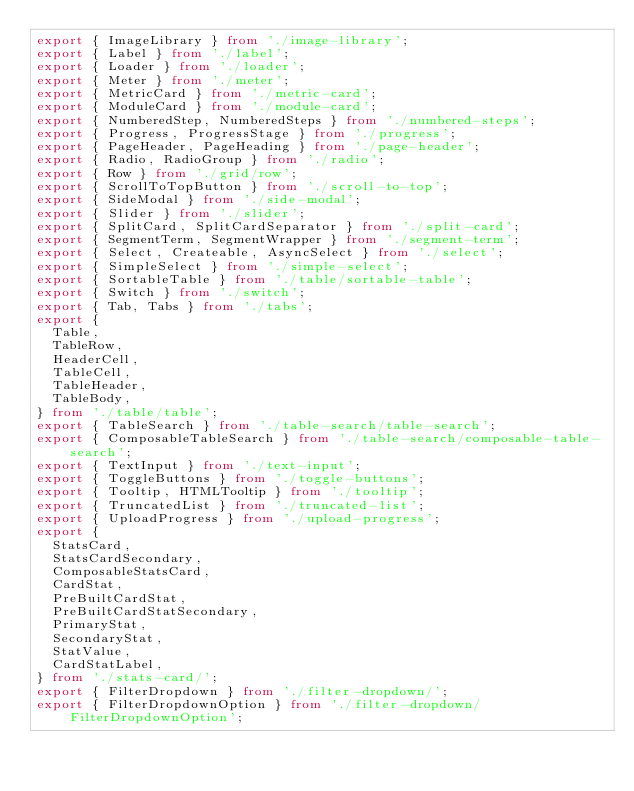<code> <loc_0><loc_0><loc_500><loc_500><_TypeScript_>export { ImageLibrary } from './image-library';
export { Label } from './label';
export { Loader } from './loader';
export { Meter } from './meter';
export { MetricCard } from './metric-card';
export { ModuleCard } from './module-card';
export { NumberedStep, NumberedSteps } from './numbered-steps';
export { Progress, ProgressStage } from './progress';
export { PageHeader, PageHeading } from './page-header';
export { Radio, RadioGroup } from './radio';
export { Row } from './grid/row';
export { ScrollToTopButton } from './scroll-to-top';
export { SideModal } from './side-modal';
export { Slider } from './slider';
export { SplitCard, SplitCardSeparator } from './split-card';
export { SegmentTerm, SegmentWrapper } from './segment-term';
export { Select, Createable, AsyncSelect } from './select';
export { SimpleSelect } from './simple-select';
export { SortableTable } from './table/sortable-table';
export { Switch } from './switch';
export { Tab, Tabs } from './tabs';
export {
  Table,
  TableRow,
  HeaderCell,
  TableCell,
  TableHeader,
  TableBody,
} from './table/table';
export { TableSearch } from './table-search/table-search';
export { ComposableTableSearch } from './table-search/composable-table-search';
export { TextInput } from './text-input';
export { ToggleButtons } from './toggle-buttons';
export { Tooltip, HTMLTooltip } from './tooltip';
export { TruncatedList } from './truncated-list';
export { UploadProgress } from './upload-progress';
export {
  StatsCard,
  StatsCardSecondary,
  ComposableStatsCard,
  CardStat,
  PreBuiltCardStat,
  PreBuiltCardStatSecondary,
  PrimaryStat,
  SecondaryStat,
  StatValue,
  CardStatLabel,
} from './stats-card/';
export { FilterDropdown } from './filter-dropdown/';
export { FilterDropdownOption } from './filter-dropdown/FilterDropdownOption';
</code> 